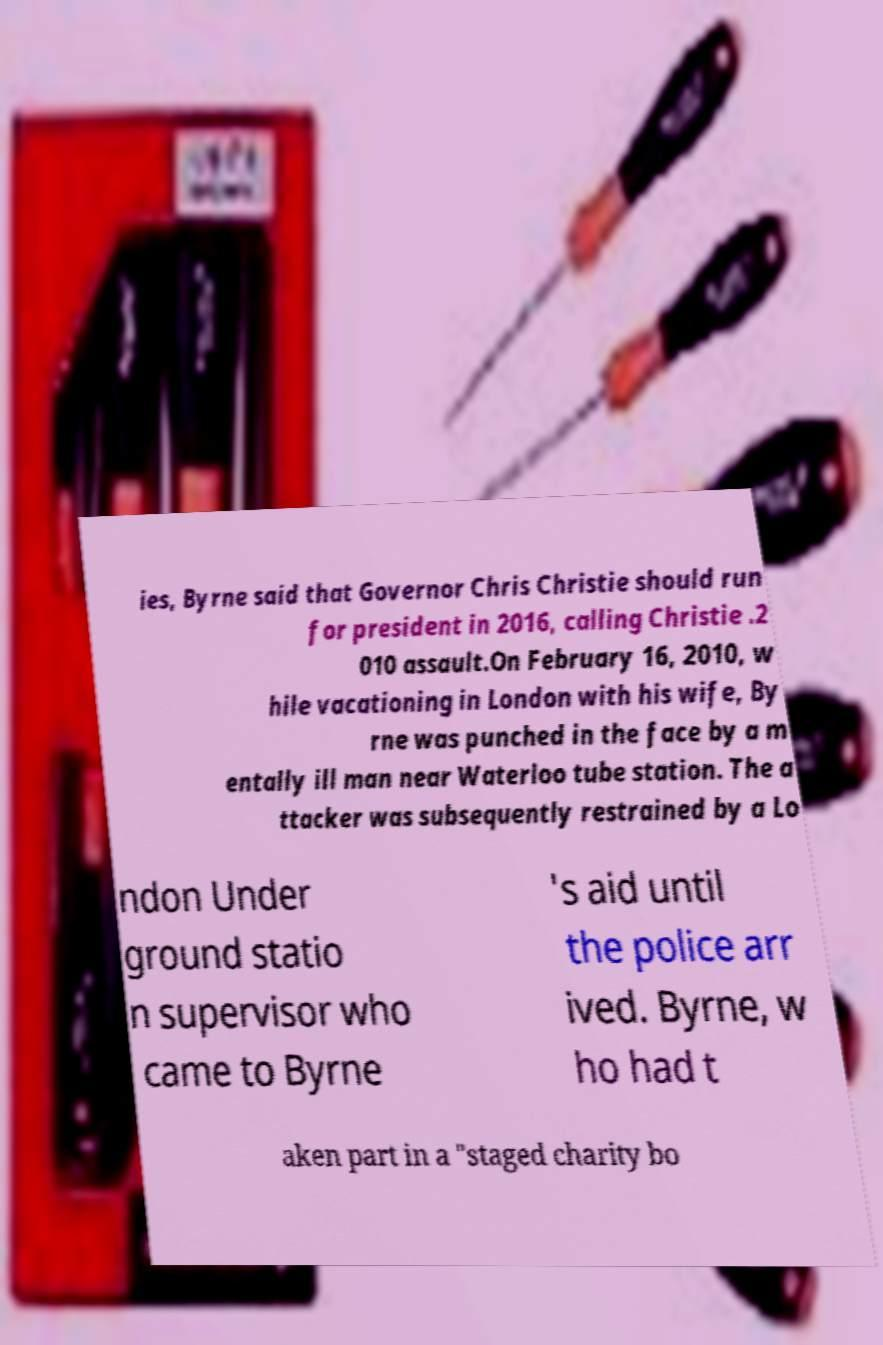For documentation purposes, I need the text within this image transcribed. Could you provide that? ies, Byrne said that Governor Chris Christie should run for president in 2016, calling Christie .2 010 assault.On February 16, 2010, w hile vacationing in London with his wife, By rne was punched in the face by a m entally ill man near Waterloo tube station. The a ttacker was subsequently restrained by a Lo ndon Under ground statio n supervisor who came to Byrne 's aid until the police arr ived. Byrne, w ho had t aken part in a "staged charity bo 